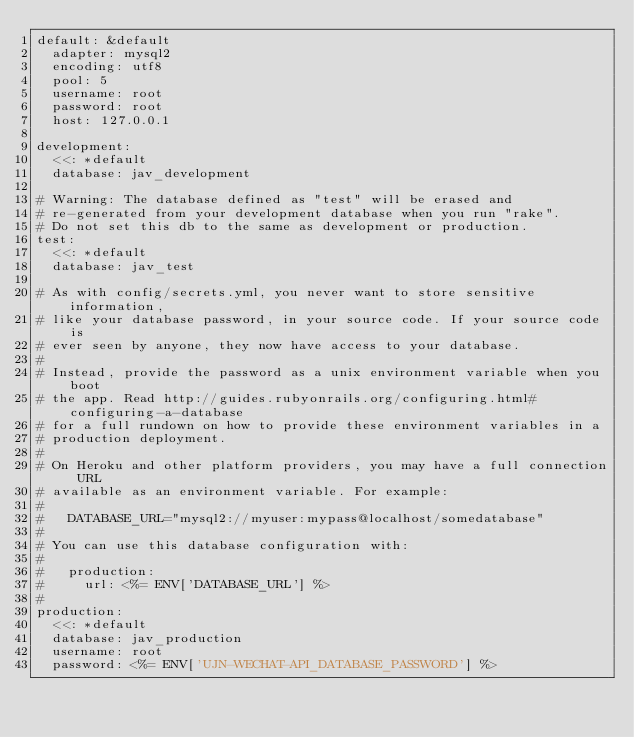Convert code to text. <code><loc_0><loc_0><loc_500><loc_500><_YAML_>default: &default
  adapter: mysql2
  encoding: utf8
  pool: 5
  username: root
  password: root
  host: 127.0.0.1

development:
  <<: *default
  database: jav_development

# Warning: The database defined as "test" will be erased and
# re-generated from your development database when you run "rake".
# Do not set this db to the same as development or production.
test:
  <<: *default
  database: jav_test

# As with config/secrets.yml, you never want to store sensitive information,
# like your database password, in your source code. If your source code is
# ever seen by anyone, they now have access to your database.
#
# Instead, provide the password as a unix environment variable when you boot
# the app. Read http://guides.rubyonrails.org/configuring.html#configuring-a-database
# for a full rundown on how to provide these environment variables in a
# production deployment.
#
# On Heroku and other platform providers, you may have a full connection URL
# available as an environment variable. For example:
#
#   DATABASE_URL="mysql2://myuser:mypass@localhost/somedatabase"
#
# You can use this database configuration with:
#
#   production:
#     url: <%= ENV['DATABASE_URL'] %>
#
production:
  <<: *default
  database: jav_production
  username: root
  password: <%= ENV['UJN-WECHAT-API_DATABASE_PASSWORD'] %>
</code> 